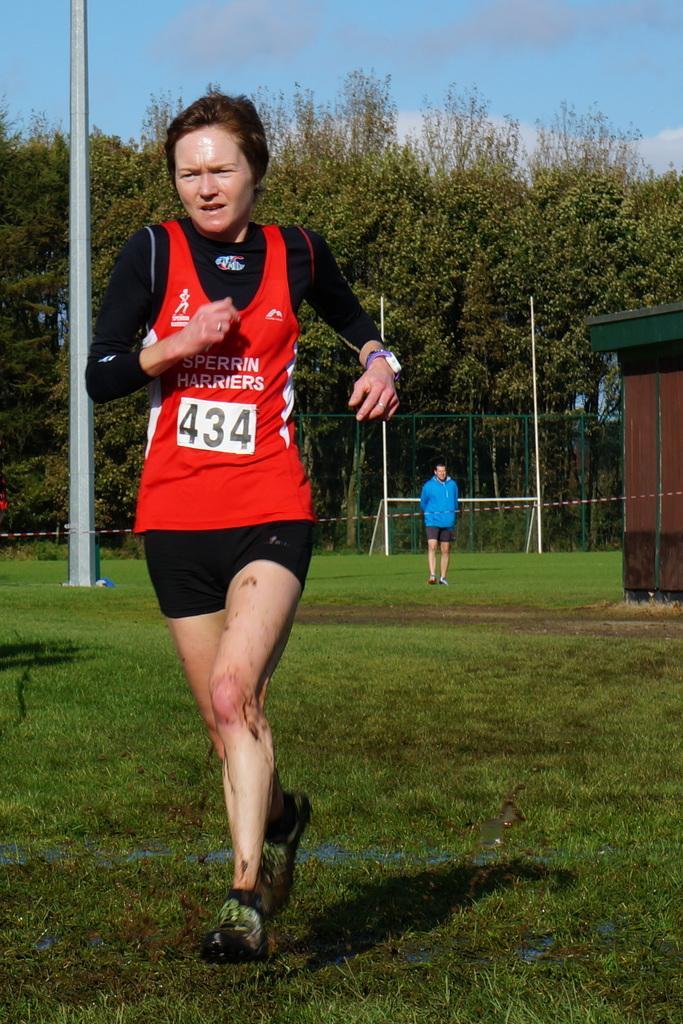Please provide a concise description of this image. In this image we can see a lady wearing watch. She is running. On the ground there is grass. In the back there are poles. Also we can see a person. In the background there are trees. On the right side we can see a shed. And there is sky with clouds. 